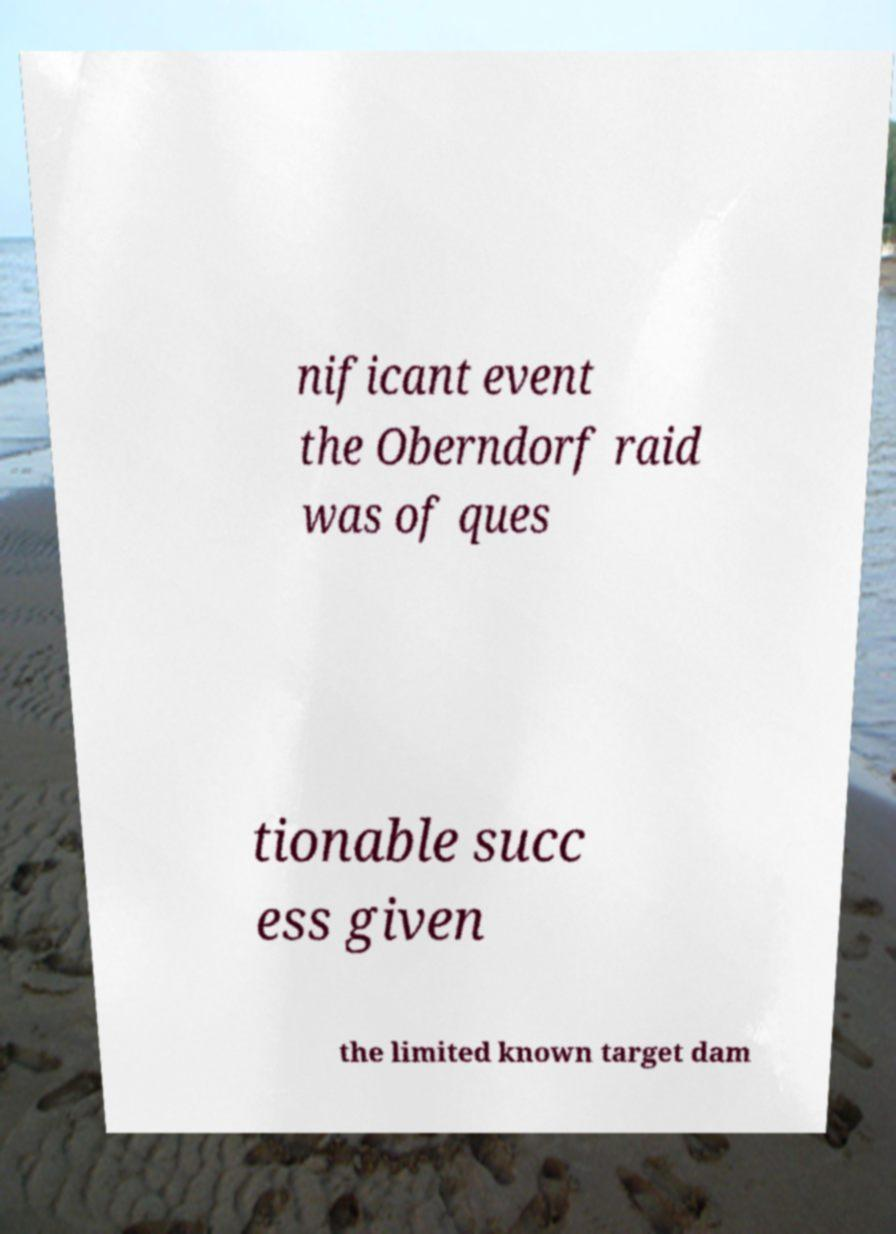For documentation purposes, I need the text within this image transcribed. Could you provide that? nificant event the Oberndorf raid was of ques tionable succ ess given the limited known target dam 